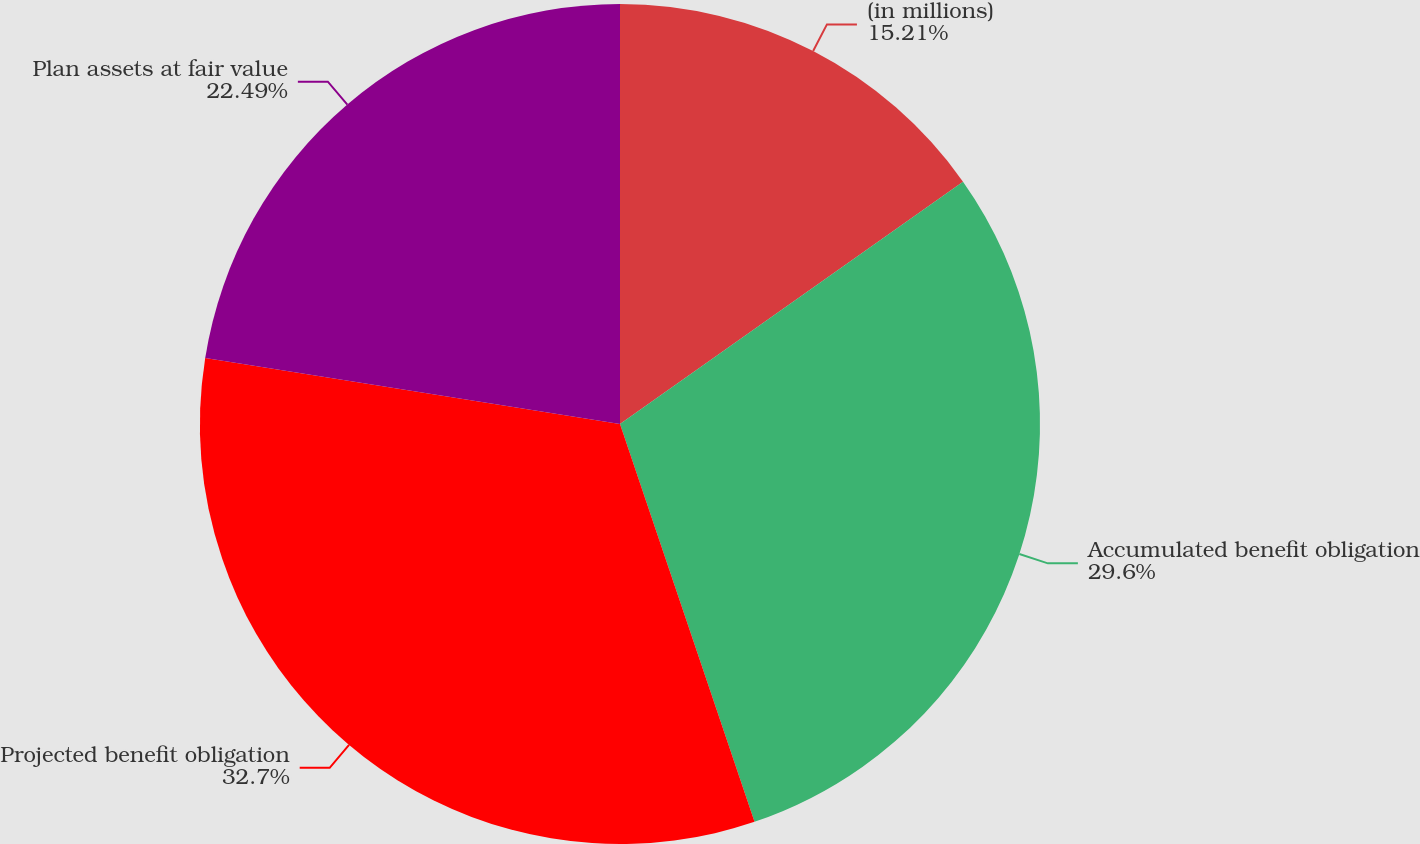Convert chart to OTSL. <chart><loc_0><loc_0><loc_500><loc_500><pie_chart><fcel>(in millions)<fcel>Accumulated benefit obligation<fcel>Projected benefit obligation<fcel>Plan assets at fair value<nl><fcel>15.21%<fcel>29.6%<fcel>32.7%<fcel>22.49%<nl></chart> 